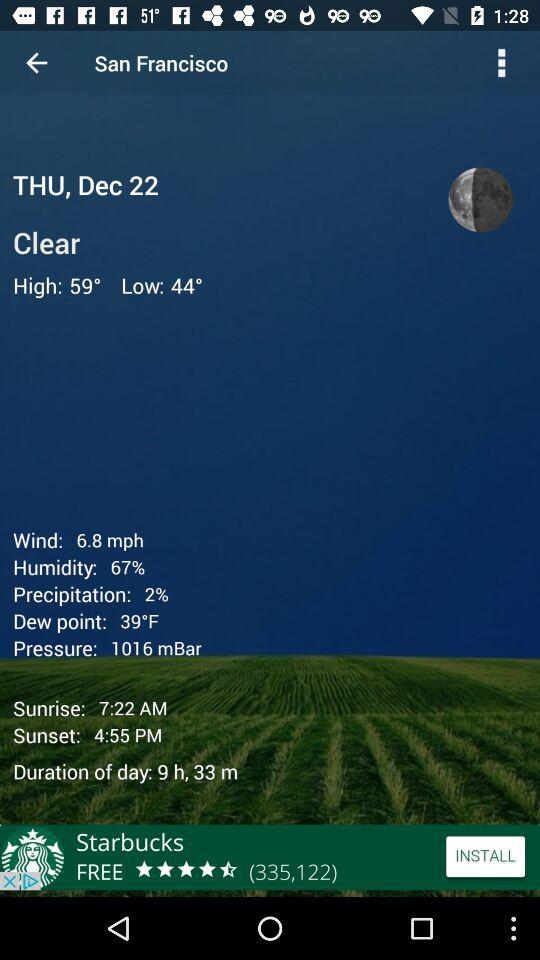What is the sunset time in San Francisco? The sunset time is 4:55 p.m. 